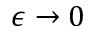<formula> <loc_0><loc_0><loc_500><loc_500>\epsilon \to 0</formula> 